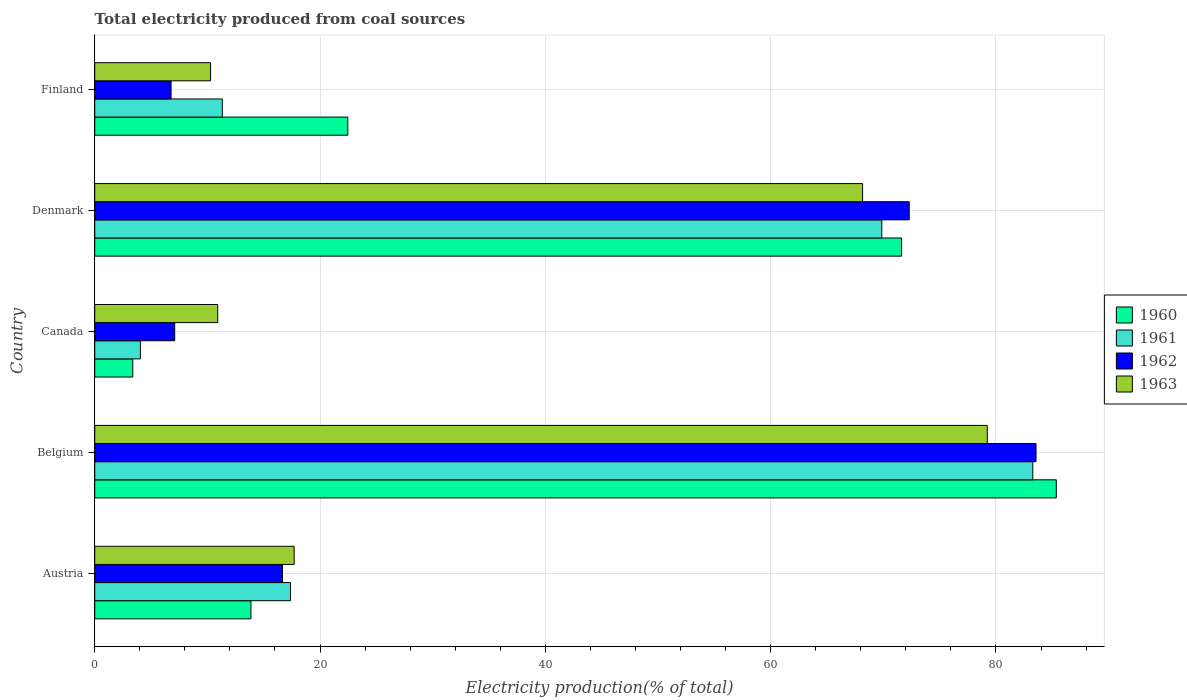How many different coloured bars are there?
Ensure brevity in your answer.  4. Are the number of bars per tick equal to the number of legend labels?
Offer a very short reply. Yes. Are the number of bars on each tick of the Y-axis equal?
Your response must be concise. Yes. How many bars are there on the 2nd tick from the top?
Your answer should be very brief. 4. How many bars are there on the 4th tick from the bottom?
Your answer should be compact. 4. In how many cases, is the number of bars for a given country not equal to the number of legend labels?
Provide a succinct answer. 0. What is the total electricity produced in 1960 in Denmark?
Provide a succinct answer. 71.62. Across all countries, what is the maximum total electricity produced in 1960?
Your answer should be very brief. 85.36. Across all countries, what is the minimum total electricity produced in 1962?
Offer a terse response. 6.78. In which country was the total electricity produced in 1960 maximum?
Your answer should be compact. Belgium. What is the total total electricity produced in 1960 in the graph?
Your answer should be very brief. 196.69. What is the difference between the total electricity produced in 1960 in Belgium and that in Denmark?
Give a very brief answer. 13.73. What is the difference between the total electricity produced in 1960 in Belgium and the total electricity produced in 1962 in Canada?
Your answer should be very brief. 78.26. What is the average total electricity produced in 1961 per country?
Your response must be concise. 37.18. What is the difference between the total electricity produced in 1963 and total electricity produced in 1962 in Austria?
Your answer should be compact. 1.04. What is the ratio of the total electricity produced in 1962 in Austria to that in Finland?
Offer a very short reply. 2.46. Is the difference between the total electricity produced in 1963 in Canada and Finland greater than the difference between the total electricity produced in 1962 in Canada and Finland?
Your response must be concise. Yes. What is the difference between the highest and the second highest total electricity produced in 1962?
Provide a short and direct response. 11.26. What is the difference between the highest and the lowest total electricity produced in 1962?
Provide a succinct answer. 76.78. Are all the bars in the graph horizontal?
Provide a short and direct response. Yes. How many countries are there in the graph?
Offer a very short reply. 5. What is the difference between two consecutive major ticks on the X-axis?
Make the answer very short. 20. Are the values on the major ticks of X-axis written in scientific E-notation?
Offer a very short reply. No. Does the graph contain any zero values?
Provide a short and direct response. No. Where does the legend appear in the graph?
Your answer should be compact. Center right. What is the title of the graph?
Your answer should be very brief. Total electricity produced from coal sources. Does "1995" appear as one of the legend labels in the graph?
Make the answer very short. No. What is the Electricity production(% of total) in 1960 in Austria?
Your response must be concise. 13.86. What is the Electricity production(% of total) in 1961 in Austria?
Make the answer very short. 17.38. What is the Electricity production(% of total) in 1962 in Austria?
Provide a short and direct response. 16.66. What is the Electricity production(% of total) of 1963 in Austria?
Ensure brevity in your answer.  17.7. What is the Electricity production(% of total) in 1960 in Belgium?
Your response must be concise. 85.36. What is the Electricity production(% of total) in 1961 in Belgium?
Keep it short and to the point. 83.27. What is the Electricity production(% of total) in 1962 in Belgium?
Provide a short and direct response. 83.56. What is the Electricity production(% of total) in 1963 in Belgium?
Provide a succinct answer. 79.23. What is the Electricity production(% of total) of 1960 in Canada?
Provide a succinct answer. 3.38. What is the Electricity production(% of total) in 1961 in Canada?
Offer a very short reply. 4.05. What is the Electricity production(% of total) in 1962 in Canada?
Give a very brief answer. 7.1. What is the Electricity production(% of total) of 1963 in Canada?
Keep it short and to the point. 10.92. What is the Electricity production(% of total) in 1960 in Denmark?
Your answer should be very brief. 71.62. What is the Electricity production(% of total) of 1961 in Denmark?
Provide a succinct answer. 69.86. What is the Electricity production(% of total) in 1962 in Denmark?
Your response must be concise. 72.3. What is the Electricity production(% of total) in 1963 in Denmark?
Your answer should be very brief. 68.16. What is the Electricity production(% of total) of 1960 in Finland?
Provide a short and direct response. 22.46. What is the Electricity production(% of total) of 1961 in Finland?
Keep it short and to the point. 11.33. What is the Electricity production(% of total) in 1962 in Finland?
Keep it short and to the point. 6.78. What is the Electricity production(% of total) of 1963 in Finland?
Offer a very short reply. 10.28. Across all countries, what is the maximum Electricity production(% of total) in 1960?
Your answer should be very brief. 85.36. Across all countries, what is the maximum Electricity production(% of total) in 1961?
Your answer should be very brief. 83.27. Across all countries, what is the maximum Electricity production(% of total) of 1962?
Make the answer very short. 83.56. Across all countries, what is the maximum Electricity production(% of total) in 1963?
Provide a short and direct response. 79.23. Across all countries, what is the minimum Electricity production(% of total) of 1960?
Your response must be concise. 3.38. Across all countries, what is the minimum Electricity production(% of total) in 1961?
Provide a short and direct response. 4.05. Across all countries, what is the minimum Electricity production(% of total) of 1962?
Ensure brevity in your answer.  6.78. Across all countries, what is the minimum Electricity production(% of total) of 1963?
Ensure brevity in your answer.  10.28. What is the total Electricity production(% of total) in 1960 in the graph?
Your answer should be very brief. 196.69. What is the total Electricity production(% of total) of 1961 in the graph?
Offer a terse response. 185.89. What is the total Electricity production(% of total) of 1962 in the graph?
Give a very brief answer. 186.4. What is the total Electricity production(% of total) of 1963 in the graph?
Give a very brief answer. 186.29. What is the difference between the Electricity production(% of total) in 1960 in Austria and that in Belgium?
Give a very brief answer. -71.49. What is the difference between the Electricity production(% of total) of 1961 in Austria and that in Belgium?
Provide a succinct answer. -65.89. What is the difference between the Electricity production(% of total) in 1962 in Austria and that in Belgium?
Provide a succinct answer. -66.89. What is the difference between the Electricity production(% of total) of 1963 in Austria and that in Belgium?
Your answer should be very brief. -61.53. What is the difference between the Electricity production(% of total) of 1960 in Austria and that in Canada?
Make the answer very short. 10.49. What is the difference between the Electricity production(% of total) of 1961 in Austria and that in Canada?
Provide a short and direct response. 13.32. What is the difference between the Electricity production(% of total) of 1962 in Austria and that in Canada?
Your answer should be compact. 9.57. What is the difference between the Electricity production(% of total) in 1963 in Austria and that in Canada?
Ensure brevity in your answer.  6.79. What is the difference between the Electricity production(% of total) of 1960 in Austria and that in Denmark?
Provide a succinct answer. -57.76. What is the difference between the Electricity production(% of total) in 1961 in Austria and that in Denmark?
Your response must be concise. -52.49. What is the difference between the Electricity production(% of total) in 1962 in Austria and that in Denmark?
Give a very brief answer. -55.64. What is the difference between the Electricity production(% of total) of 1963 in Austria and that in Denmark?
Offer a terse response. -50.46. What is the difference between the Electricity production(% of total) in 1960 in Austria and that in Finland?
Your response must be concise. -8.6. What is the difference between the Electricity production(% of total) in 1961 in Austria and that in Finland?
Ensure brevity in your answer.  6.05. What is the difference between the Electricity production(% of total) in 1962 in Austria and that in Finland?
Provide a succinct answer. 9.89. What is the difference between the Electricity production(% of total) of 1963 in Austria and that in Finland?
Ensure brevity in your answer.  7.42. What is the difference between the Electricity production(% of total) of 1960 in Belgium and that in Canada?
Keep it short and to the point. 81.98. What is the difference between the Electricity production(% of total) in 1961 in Belgium and that in Canada?
Offer a terse response. 79.21. What is the difference between the Electricity production(% of total) of 1962 in Belgium and that in Canada?
Provide a short and direct response. 76.46. What is the difference between the Electricity production(% of total) in 1963 in Belgium and that in Canada?
Your answer should be very brief. 68.31. What is the difference between the Electricity production(% of total) of 1960 in Belgium and that in Denmark?
Your answer should be compact. 13.73. What is the difference between the Electricity production(% of total) in 1961 in Belgium and that in Denmark?
Your response must be concise. 13.4. What is the difference between the Electricity production(% of total) of 1962 in Belgium and that in Denmark?
Offer a very short reply. 11.26. What is the difference between the Electricity production(% of total) of 1963 in Belgium and that in Denmark?
Your response must be concise. 11.07. What is the difference between the Electricity production(% of total) of 1960 in Belgium and that in Finland?
Provide a short and direct response. 62.89. What is the difference between the Electricity production(% of total) in 1961 in Belgium and that in Finland?
Your answer should be very brief. 71.94. What is the difference between the Electricity production(% of total) in 1962 in Belgium and that in Finland?
Keep it short and to the point. 76.78. What is the difference between the Electricity production(% of total) in 1963 in Belgium and that in Finland?
Keep it short and to the point. 68.95. What is the difference between the Electricity production(% of total) in 1960 in Canada and that in Denmark?
Your response must be concise. -68.25. What is the difference between the Electricity production(% of total) of 1961 in Canada and that in Denmark?
Provide a succinct answer. -65.81. What is the difference between the Electricity production(% of total) of 1962 in Canada and that in Denmark?
Your answer should be very brief. -65.2. What is the difference between the Electricity production(% of total) in 1963 in Canada and that in Denmark?
Offer a terse response. -57.24. What is the difference between the Electricity production(% of total) of 1960 in Canada and that in Finland?
Ensure brevity in your answer.  -19.09. What is the difference between the Electricity production(% of total) in 1961 in Canada and that in Finland?
Keep it short and to the point. -7.27. What is the difference between the Electricity production(% of total) in 1962 in Canada and that in Finland?
Keep it short and to the point. 0.32. What is the difference between the Electricity production(% of total) of 1963 in Canada and that in Finland?
Offer a terse response. 0.63. What is the difference between the Electricity production(% of total) of 1960 in Denmark and that in Finland?
Your answer should be compact. 49.16. What is the difference between the Electricity production(% of total) in 1961 in Denmark and that in Finland?
Your answer should be compact. 58.54. What is the difference between the Electricity production(% of total) in 1962 in Denmark and that in Finland?
Your answer should be compact. 65.53. What is the difference between the Electricity production(% of total) in 1963 in Denmark and that in Finland?
Provide a succinct answer. 57.88. What is the difference between the Electricity production(% of total) of 1960 in Austria and the Electricity production(% of total) of 1961 in Belgium?
Your answer should be compact. -69.4. What is the difference between the Electricity production(% of total) of 1960 in Austria and the Electricity production(% of total) of 1962 in Belgium?
Your answer should be very brief. -69.69. What is the difference between the Electricity production(% of total) of 1960 in Austria and the Electricity production(% of total) of 1963 in Belgium?
Provide a succinct answer. -65.37. What is the difference between the Electricity production(% of total) in 1961 in Austria and the Electricity production(% of total) in 1962 in Belgium?
Ensure brevity in your answer.  -66.18. What is the difference between the Electricity production(% of total) of 1961 in Austria and the Electricity production(% of total) of 1963 in Belgium?
Offer a terse response. -61.86. What is the difference between the Electricity production(% of total) in 1962 in Austria and the Electricity production(% of total) in 1963 in Belgium?
Give a very brief answer. -62.57. What is the difference between the Electricity production(% of total) of 1960 in Austria and the Electricity production(% of total) of 1961 in Canada?
Provide a short and direct response. 9.81. What is the difference between the Electricity production(% of total) in 1960 in Austria and the Electricity production(% of total) in 1962 in Canada?
Make the answer very short. 6.77. What is the difference between the Electricity production(% of total) in 1960 in Austria and the Electricity production(% of total) in 1963 in Canada?
Ensure brevity in your answer.  2.95. What is the difference between the Electricity production(% of total) in 1961 in Austria and the Electricity production(% of total) in 1962 in Canada?
Ensure brevity in your answer.  10.28. What is the difference between the Electricity production(% of total) in 1961 in Austria and the Electricity production(% of total) in 1963 in Canada?
Your response must be concise. 6.46. What is the difference between the Electricity production(% of total) of 1962 in Austria and the Electricity production(% of total) of 1963 in Canada?
Keep it short and to the point. 5.75. What is the difference between the Electricity production(% of total) of 1960 in Austria and the Electricity production(% of total) of 1961 in Denmark?
Make the answer very short. -56. What is the difference between the Electricity production(% of total) in 1960 in Austria and the Electricity production(% of total) in 1962 in Denmark?
Your answer should be very brief. -58.44. What is the difference between the Electricity production(% of total) in 1960 in Austria and the Electricity production(% of total) in 1963 in Denmark?
Provide a succinct answer. -54.3. What is the difference between the Electricity production(% of total) in 1961 in Austria and the Electricity production(% of total) in 1962 in Denmark?
Ensure brevity in your answer.  -54.92. What is the difference between the Electricity production(% of total) of 1961 in Austria and the Electricity production(% of total) of 1963 in Denmark?
Give a very brief answer. -50.78. What is the difference between the Electricity production(% of total) of 1962 in Austria and the Electricity production(% of total) of 1963 in Denmark?
Make the answer very short. -51.5. What is the difference between the Electricity production(% of total) in 1960 in Austria and the Electricity production(% of total) in 1961 in Finland?
Ensure brevity in your answer.  2.54. What is the difference between the Electricity production(% of total) of 1960 in Austria and the Electricity production(% of total) of 1962 in Finland?
Keep it short and to the point. 7.09. What is the difference between the Electricity production(% of total) of 1960 in Austria and the Electricity production(% of total) of 1963 in Finland?
Give a very brief answer. 3.58. What is the difference between the Electricity production(% of total) in 1961 in Austria and the Electricity production(% of total) in 1962 in Finland?
Provide a short and direct response. 10.6. What is the difference between the Electricity production(% of total) in 1961 in Austria and the Electricity production(% of total) in 1963 in Finland?
Your answer should be compact. 7.09. What is the difference between the Electricity production(% of total) of 1962 in Austria and the Electricity production(% of total) of 1963 in Finland?
Make the answer very short. 6.38. What is the difference between the Electricity production(% of total) of 1960 in Belgium and the Electricity production(% of total) of 1961 in Canada?
Provide a short and direct response. 81.3. What is the difference between the Electricity production(% of total) of 1960 in Belgium and the Electricity production(% of total) of 1962 in Canada?
Offer a very short reply. 78.26. What is the difference between the Electricity production(% of total) in 1960 in Belgium and the Electricity production(% of total) in 1963 in Canada?
Give a very brief answer. 74.44. What is the difference between the Electricity production(% of total) in 1961 in Belgium and the Electricity production(% of total) in 1962 in Canada?
Provide a succinct answer. 76.17. What is the difference between the Electricity production(% of total) of 1961 in Belgium and the Electricity production(% of total) of 1963 in Canada?
Keep it short and to the point. 72.35. What is the difference between the Electricity production(% of total) in 1962 in Belgium and the Electricity production(% of total) in 1963 in Canada?
Keep it short and to the point. 72.64. What is the difference between the Electricity production(% of total) in 1960 in Belgium and the Electricity production(% of total) in 1961 in Denmark?
Give a very brief answer. 15.49. What is the difference between the Electricity production(% of total) in 1960 in Belgium and the Electricity production(% of total) in 1962 in Denmark?
Provide a short and direct response. 13.05. What is the difference between the Electricity production(% of total) in 1960 in Belgium and the Electricity production(% of total) in 1963 in Denmark?
Ensure brevity in your answer.  17.19. What is the difference between the Electricity production(% of total) in 1961 in Belgium and the Electricity production(% of total) in 1962 in Denmark?
Your response must be concise. 10.97. What is the difference between the Electricity production(% of total) in 1961 in Belgium and the Electricity production(% of total) in 1963 in Denmark?
Your answer should be compact. 15.11. What is the difference between the Electricity production(% of total) in 1962 in Belgium and the Electricity production(% of total) in 1963 in Denmark?
Offer a terse response. 15.4. What is the difference between the Electricity production(% of total) in 1960 in Belgium and the Electricity production(% of total) in 1961 in Finland?
Your response must be concise. 74.03. What is the difference between the Electricity production(% of total) of 1960 in Belgium and the Electricity production(% of total) of 1962 in Finland?
Provide a short and direct response. 78.58. What is the difference between the Electricity production(% of total) in 1960 in Belgium and the Electricity production(% of total) in 1963 in Finland?
Your answer should be very brief. 75.07. What is the difference between the Electricity production(% of total) in 1961 in Belgium and the Electricity production(% of total) in 1962 in Finland?
Provide a succinct answer. 76.49. What is the difference between the Electricity production(% of total) in 1961 in Belgium and the Electricity production(% of total) in 1963 in Finland?
Your answer should be very brief. 72.98. What is the difference between the Electricity production(% of total) in 1962 in Belgium and the Electricity production(% of total) in 1963 in Finland?
Provide a short and direct response. 73.27. What is the difference between the Electricity production(% of total) of 1960 in Canada and the Electricity production(% of total) of 1961 in Denmark?
Your answer should be compact. -66.49. What is the difference between the Electricity production(% of total) of 1960 in Canada and the Electricity production(% of total) of 1962 in Denmark?
Make the answer very short. -68.92. What is the difference between the Electricity production(% of total) of 1960 in Canada and the Electricity production(% of total) of 1963 in Denmark?
Offer a very short reply. -64.78. What is the difference between the Electricity production(% of total) of 1961 in Canada and the Electricity production(% of total) of 1962 in Denmark?
Offer a very short reply. -68.25. What is the difference between the Electricity production(% of total) in 1961 in Canada and the Electricity production(% of total) in 1963 in Denmark?
Keep it short and to the point. -64.11. What is the difference between the Electricity production(% of total) of 1962 in Canada and the Electricity production(% of total) of 1963 in Denmark?
Your response must be concise. -61.06. What is the difference between the Electricity production(% of total) of 1960 in Canada and the Electricity production(% of total) of 1961 in Finland?
Provide a succinct answer. -7.95. What is the difference between the Electricity production(% of total) in 1960 in Canada and the Electricity production(% of total) in 1962 in Finland?
Keep it short and to the point. -3.4. What is the difference between the Electricity production(% of total) of 1960 in Canada and the Electricity production(% of total) of 1963 in Finland?
Keep it short and to the point. -6.91. What is the difference between the Electricity production(% of total) in 1961 in Canada and the Electricity production(% of total) in 1962 in Finland?
Keep it short and to the point. -2.72. What is the difference between the Electricity production(% of total) in 1961 in Canada and the Electricity production(% of total) in 1963 in Finland?
Give a very brief answer. -6.23. What is the difference between the Electricity production(% of total) of 1962 in Canada and the Electricity production(% of total) of 1963 in Finland?
Provide a succinct answer. -3.18. What is the difference between the Electricity production(% of total) of 1960 in Denmark and the Electricity production(% of total) of 1961 in Finland?
Give a very brief answer. 60.3. What is the difference between the Electricity production(% of total) of 1960 in Denmark and the Electricity production(% of total) of 1962 in Finland?
Provide a short and direct response. 64.85. What is the difference between the Electricity production(% of total) of 1960 in Denmark and the Electricity production(% of total) of 1963 in Finland?
Offer a very short reply. 61.34. What is the difference between the Electricity production(% of total) in 1961 in Denmark and the Electricity production(% of total) in 1962 in Finland?
Your answer should be compact. 63.09. What is the difference between the Electricity production(% of total) of 1961 in Denmark and the Electricity production(% of total) of 1963 in Finland?
Your response must be concise. 59.58. What is the difference between the Electricity production(% of total) in 1962 in Denmark and the Electricity production(% of total) in 1963 in Finland?
Provide a short and direct response. 62.02. What is the average Electricity production(% of total) in 1960 per country?
Your answer should be compact. 39.34. What is the average Electricity production(% of total) in 1961 per country?
Offer a terse response. 37.18. What is the average Electricity production(% of total) of 1962 per country?
Offer a terse response. 37.28. What is the average Electricity production(% of total) in 1963 per country?
Make the answer very short. 37.26. What is the difference between the Electricity production(% of total) in 1960 and Electricity production(% of total) in 1961 in Austria?
Keep it short and to the point. -3.51. What is the difference between the Electricity production(% of total) in 1960 and Electricity production(% of total) in 1962 in Austria?
Ensure brevity in your answer.  -2.8. What is the difference between the Electricity production(% of total) in 1960 and Electricity production(% of total) in 1963 in Austria?
Your response must be concise. -3.84. What is the difference between the Electricity production(% of total) in 1961 and Electricity production(% of total) in 1962 in Austria?
Ensure brevity in your answer.  0.71. What is the difference between the Electricity production(% of total) in 1961 and Electricity production(% of total) in 1963 in Austria?
Provide a succinct answer. -0.33. What is the difference between the Electricity production(% of total) of 1962 and Electricity production(% of total) of 1963 in Austria?
Make the answer very short. -1.04. What is the difference between the Electricity production(% of total) of 1960 and Electricity production(% of total) of 1961 in Belgium?
Provide a short and direct response. 2.09. What is the difference between the Electricity production(% of total) in 1960 and Electricity production(% of total) in 1962 in Belgium?
Make the answer very short. 1.8. What is the difference between the Electricity production(% of total) of 1960 and Electricity production(% of total) of 1963 in Belgium?
Give a very brief answer. 6.12. What is the difference between the Electricity production(% of total) of 1961 and Electricity production(% of total) of 1962 in Belgium?
Ensure brevity in your answer.  -0.29. What is the difference between the Electricity production(% of total) of 1961 and Electricity production(% of total) of 1963 in Belgium?
Make the answer very short. 4.04. What is the difference between the Electricity production(% of total) of 1962 and Electricity production(% of total) of 1963 in Belgium?
Offer a very short reply. 4.33. What is the difference between the Electricity production(% of total) of 1960 and Electricity production(% of total) of 1961 in Canada?
Give a very brief answer. -0.68. What is the difference between the Electricity production(% of total) in 1960 and Electricity production(% of total) in 1962 in Canada?
Give a very brief answer. -3.72. What is the difference between the Electricity production(% of total) of 1960 and Electricity production(% of total) of 1963 in Canada?
Give a very brief answer. -7.54. What is the difference between the Electricity production(% of total) of 1961 and Electricity production(% of total) of 1962 in Canada?
Make the answer very short. -3.04. What is the difference between the Electricity production(% of total) of 1961 and Electricity production(% of total) of 1963 in Canada?
Your response must be concise. -6.86. What is the difference between the Electricity production(% of total) of 1962 and Electricity production(% of total) of 1963 in Canada?
Keep it short and to the point. -3.82. What is the difference between the Electricity production(% of total) of 1960 and Electricity production(% of total) of 1961 in Denmark?
Your answer should be compact. 1.76. What is the difference between the Electricity production(% of total) of 1960 and Electricity production(% of total) of 1962 in Denmark?
Give a very brief answer. -0.68. What is the difference between the Electricity production(% of total) of 1960 and Electricity production(% of total) of 1963 in Denmark?
Ensure brevity in your answer.  3.46. What is the difference between the Electricity production(% of total) of 1961 and Electricity production(% of total) of 1962 in Denmark?
Your response must be concise. -2.44. What is the difference between the Electricity production(% of total) in 1961 and Electricity production(% of total) in 1963 in Denmark?
Your response must be concise. 1.7. What is the difference between the Electricity production(% of total) in 1962 and Electricity production(% of total) in 1963 in Denmark?
Your response must be concise. 4.14. What is the difference between the Electricity production(% of total) in 1960 and Electricity production(% of total) in 1961 in Finland?
Provide a succinct answer. 11.14. What is the difference between the Electricity production(% of total) of 1960 and Electricity production(% of total) of 1962 in Finland?
Your answer should be compact. 15.69. What is the difference between the Electricity production(% of total) in 1960 and Electricity production(% of total) in 1963 in Finland?
Ensure brevity in your answer.  12.18. What is the difference between the Electricity production(% of total) of 1961 and Electricity production(% of total) of 1962 in Finland?
Your answer should be compact. 4.55. What is the difference between the Electricity production(% of total) in 1961 and Electricity production(% of total) in 1963 in Finland?
Provide a succinct answer. 1.04. What is the difference between the Electricity production(% of total) of 1962 and Electricity production(% of total) of 1963 in Finland?
Ensure brevity in your answer.  -3.51. What is the ratio of the Electricity production(% of total) in 1960 in Austria to that in Belgium?
Provide a succinct answer. 0.16. What is the ratio of the Electricity production(% of total) of 1961 in Austria to that in Belgium?
Provide a short and direct response. 0.21. What is the ratio of the Electricity production(% of total) of 1962 in Austria to that in Belgium?
Ensure brevity in your answer.  0.2. What is the ratio of the Electricity production(% of total) in 1963 in Austria to that in Belgium?
Provide a succinct answer. 0.22. What is the ratio of the Electricity production(% of total) of 1960 in Austria to that in Canada?
Offer a very short reply. 4.1. What is the ratio of the Electricity production(% of total) in 1961 in Austria to that in Canada?
Keep it short and to the point. 4.29. What is the ratio of the Electricity production(% of total) of 1962 in Austria to that in Canada?
Keep it short and to the point. 2.35. What is the ratio of the Electricity production(% of total) of 1963 in Austria to that in Canada?
Your answer should be compact. 1.62. What is the ratio of the Electricity production(% of total) in 1960 in Austria to that in Denmark?
Keep it short and to the point. 0.19. What is the ratio of the Electricity production(% of total) of 1961 in Austria to that in Denmark?
Ensure brevity in your answer.  0.25. What is the ratio of the Electricity production(% of total) in 1962 in Austria to that in Denmark?
Your response must be concise. 0.23. What is the ratio of the Electricity production(% of total) in 1963 in Austria to that in Denmark?
Offer a terse response. 0.26. What is the ratio of the Electricity production(% of total) in 1960 in Austria to that in Finland?
Ensure brevity in your answer.  0.62. What is the ratio of the Electricity production(% of total) in 1961 in Austria to that in Finland?
Make the answer very short. 1.53. What is the ratio of the Electricity production(% of total) of 1962 in Austria to that in Finland?
Make the answer very short. 2.46. What is the ratio of the Electricity production(% of total) in 1963 in Austria to that in Finland?
Your answer should be very brief. 1.72. What is the ratio of the Electricity production(% of total) in 1960 in Belgium to that in Canada?
Your response must be concise. 25.27. What is the ratio of the Electricity production(% of total) of 1961 in Belgium to that in Canada?
Your answer should be very brief. 20.54. What is the ratio of the Electricity production(% of total) of 1962 in Belgium to that in Canada?
Offer a terse response. 11.77. What is the ratio of the Electricity production(% of total) of 1963 in Belgium to that in Canada?
Provide a succinct answer. 7.26. What is the ratio of the Electricity production(% of total) in 1960 in Belgium to that in Denmark?
Offer a very short reply. 1.19. What is the ratio of the Electricity production(% of total) in 1961 in Belgium to that in Denmark?
Keep it short and to the point. 1.19. What is the ratio of the Electricity production(% of total) of 1962 in Belgium to that in Denmark?
Provide a succinct answer. 1.16. What is the ratio of the Electricity production(% of total) in 1963 in Belgium to that in Denmark?
Your answer should be compact. 1.16. What is the ratio of the Electricity production(% of total) in 1960 in Belgium to that in Finland?
Your response must be concise. 3.8. What is the ratio of the Electricity production(% of total) in 1961 in Belgium to that in Finland?
Offer a very short reply. 7.35. What is the ratio of the Electricity production(% of total) of 1962 in Belgium to that in Finland?
Give a very brief answer. 12.33. What is the ratio of the Electricity production(% of total) in 1963 in Belgium to that in Finland?
Make the answer very short. 7.7. What is the ratio of the Electricity production(% of total) of 1960 in Canada to that in Denmark?
Give a very brief answer. 0.05. What is the ratio of the Electricity production(% of total) of 1961 in Canada to that in Denmark?
Your response must be concise. 0.06. What is the ratio of the Electricity production(% of total) in 1962 in Canada to that in Denmark?
Give a very brief answer. 0.1. What is the ratio of the Electricity production(% of total) of 1963 in Canada to that in Denmark?
Make the answer very short. 0.16. What is the ratio of the Electricity production(% of total) in 1960 in Canada to that in Finland?
Your answer should be compact. 0.15. What is the ratio of the Electricity production(% of total) in 1961 in Canada to that in Finland?
Your response must be concise. 0.36. What is the ratio of the Electricity production(% of total) in 1962 in Canada to that in Finland?
Your response must be concise. 1.05. What is the ratio of the Electricity production(% of total) of 1963 in Canada to that in Finland?
Make the answer very short. 1.06. What is the ratio of the Electricity production(% of total) of 1960 in Denmark to that in Finland?
Your response must be concise. 3.19. What is the ratio of the Electricity production(% of total) of 1961 in Denmark to that in Finland?
Your response must be concise. 6.17. What is the ratio of the Electricity production(% of total) of 1962 in Denmark to that in Finland?
Give a very brief answer. 10.67. What is the ratio of the Electricity production(% of total) of 1963 in Denmark to that in Finland?
Provide a succinct answer. 6.63. What is the difference between the highest and the second highest Electricity production(% of total) of 1960?
Your answer should be compact. 13.73. What is the difference between the highest and the second highest Electricity production(% of total) in 1961?
Provide a short and direct response. 13.4. What is the difference between the highest and the second highest Electricity production(% of total) in 1962?
Offer a very short reply. 11.26. What is the difference between the highest and the second highest Electricity production(% of total) of 1963?
Your response must be concise. 11.07. What is the difference between the highest and the lowest Electricity production(% of total) in 1960?
Offer a very short reply. 81.98. What is the difference between the highest and the lowest Electricity production(% of total) of 1961?
Ensure brevity in your answer.  79.21. What is the difference between the highest and the lowest Electricity production(% of total) in 1962?
Make the answer very short. 76.78. What is the difference between the highest and the lowest Electricity production(% of total) of 1963?
Your answer should be compact. 68.95. 